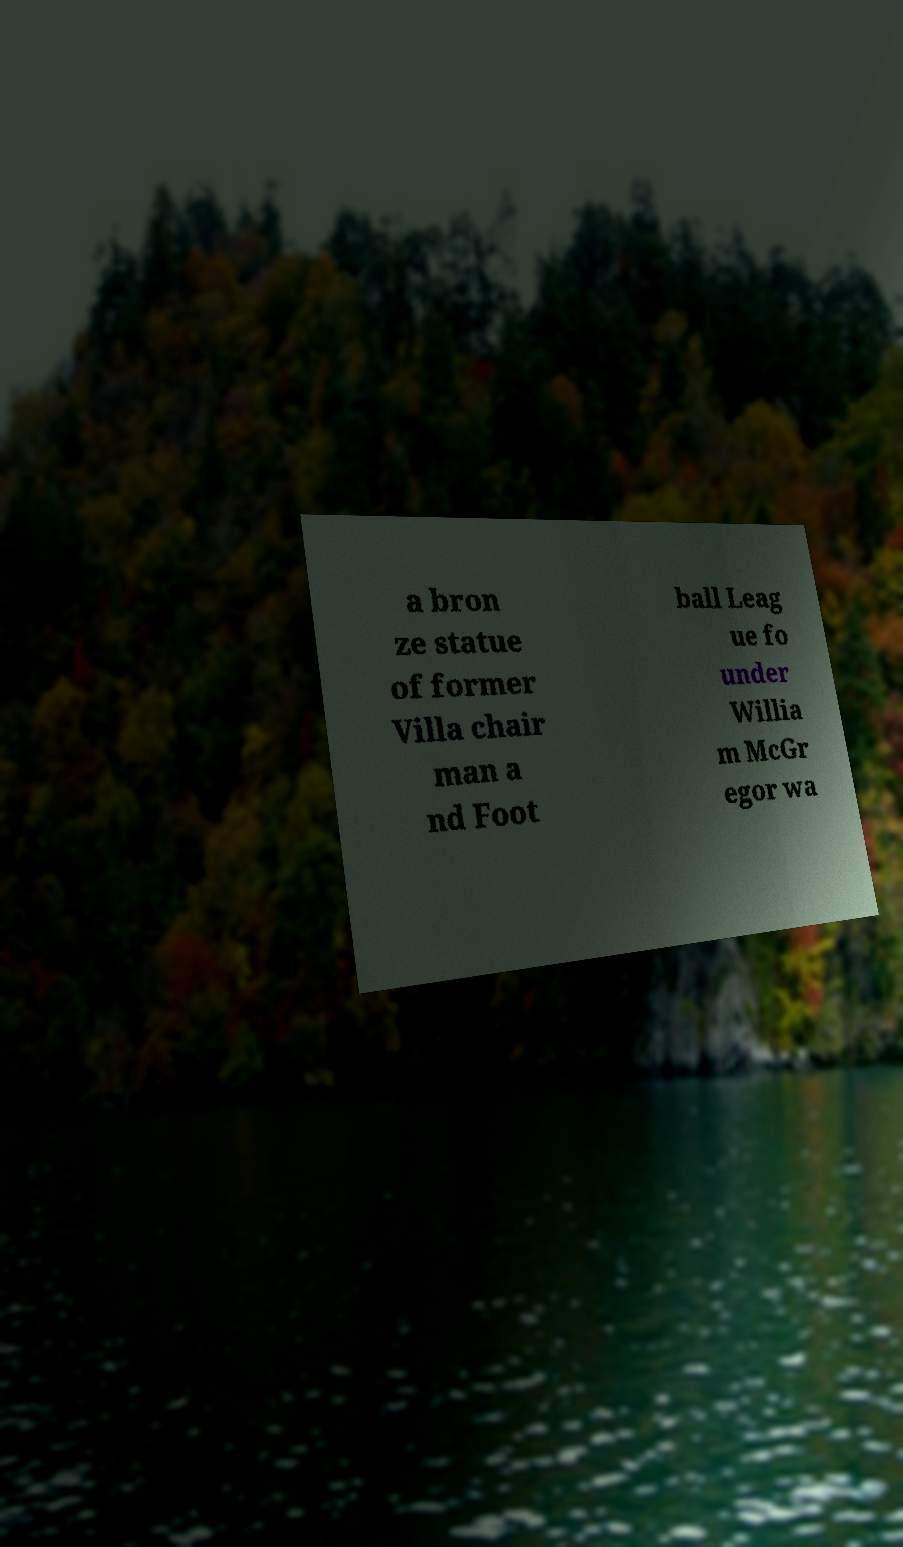For documentation purposes, I need the text within this image transcribed. Could you provide that? a bron ze statue of former Villa chair man a nd Foot ball Leag ue fo under Willia m McGr egor wa 